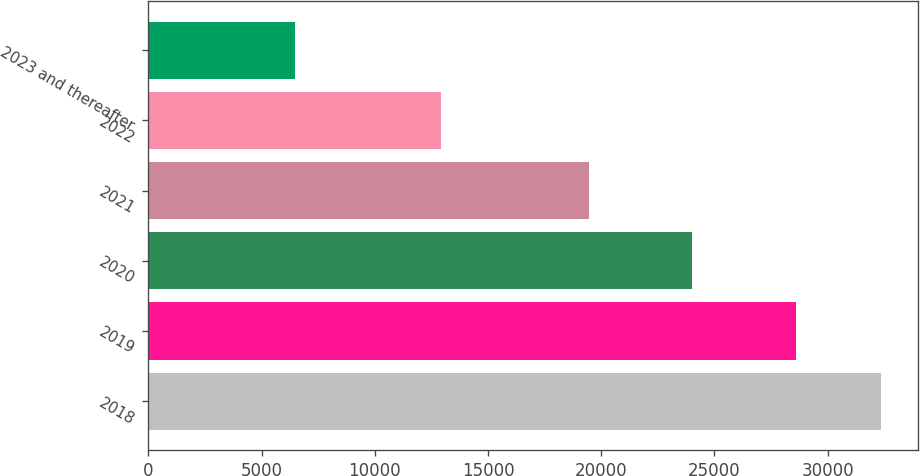Convert chart. <chart><loc_0><loc_0><loc_500><loc_500><bar_chart><fcel>2018<fcel>2019<fcel>2020<fcel>2021<fcel>2022<fcel>2023 and thereafter<nl><fcel>32371<fcel>28605<fcel>24012<fcel>19452<fcel>12914<fcel>6463<nl></chart> 